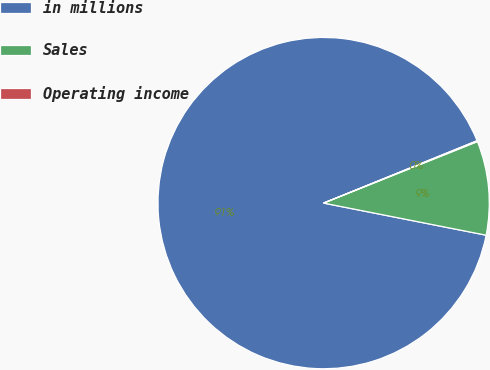Convert chart. <chart><loc_0><loc_0><loc_500><loc_500><pie_chart><fcel>in millions<fcel>Sales<fcel>Operating income<nl><fcel>90.75%<fcel>9.16%<fcel>0.09%<nl></chart> 